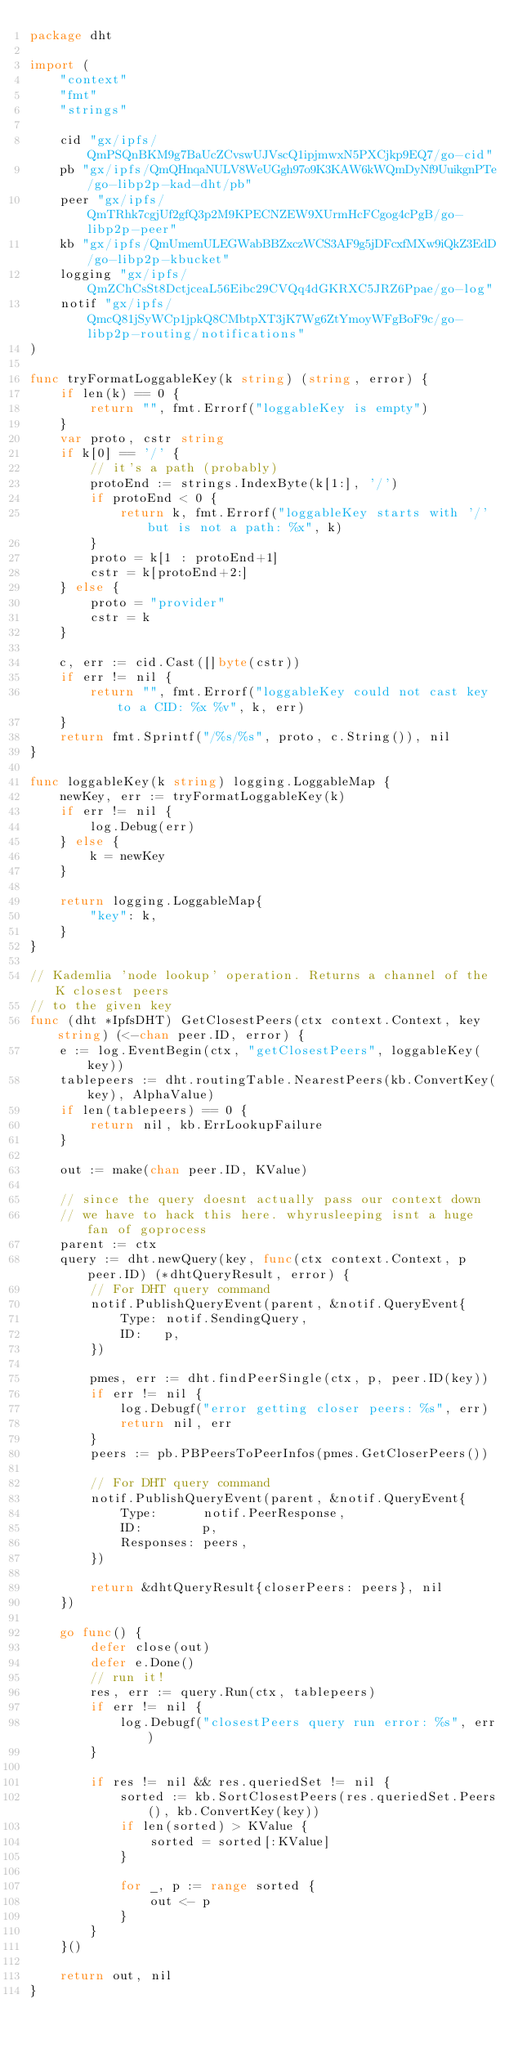Convert code to text. <code><loc_0><loc_0><loc_500><loc_500><_Go_>package dht

import (
	"context"
	"fmt"
	"strings"

	cid "gx/ipfs/QmPSQnBKM9g7BaUcZCvswUJVscQ1ipjmwxN5PXCjkp9EQ7/go-cid"
	pb "gx/ipfs/QmQHnqaNULV8WeUGgh97o9K3KAW6kWQmDyNf9UuikgnPTe/go-libp2p-kad-dht/pb"
	peer "gx/ipfs/QmTRhk7cgjUf2gfQ3p2M9KPECNZEW9XUrmHcFCgog4cPgB/go-libp2p-peer"
	kb "gx/ipfs/QmUmemULEGWabBBZxczWCS3AF9g5jDFcxfMXw9iQkZ3EdD/go-libp2p-kbucket"
	logging "gx/ipfs/QmZChCsSt8DctjceaL56Eibc29CVQq4dGKRXC5JRZ6Ppae/go-log"
	notif "gx/ipfs/QmcQ81jSyWCp1jpkQ8CMbtpXT3jK7Wg6ZtYmoyWFgBoF9c/go-libp2p-routing/notifications"
)

func tryFormatLoggableKey(k string) (string, error) {
	if len(k) == 0 {
		return "", fmt.Errorf("loggableKey is empty")
	}
	var proto, cstr string
	if k[0] == '/' {
		// it's a path (probably)
		protoEnd := strings.IndexByte(k[1:], '/')
		if protoEnd < 0 {
			return k, fmt.Errorf("loggableKey starts with '/' but is not a path: %x", k)
		}
		proto = k[1 : protoEnd+1]
		cstr = k[protoEnd+2:]
	} else {
		proto = "provider"
		cstr = k
	}

	c, err := cid.Cast([]byte(cstr))
	if err != nil {
		return "", fmt.Errorf("loggableKey could not cast key to a CID: %x %v", k, err)
	}
	return fmt.Sprintf("/%s/%s", proto, c.String()), nil
}

func loggableKey(k string) logging.LoggableMap {
	newKey, err := tryFormatLoggableKey(k)
	if err != nil {
		log.Debug(err)
	} else {
		k = newKey
	}

	return logging.LoggableMap{
		"key": k,
	}
}

// Kademlia 'node lookup' operation. Returns a channel of the K closest peers
// to the given key
func (dht *IpfsDHT) GetClosestPeers(ctx context.Context, key string) (<-chan peer.ID, error) {
	e := log.EventBegin(ctx, "getClosestPeers", loggableKey(key))
	tablepeers := dht.routingTable.NearestPeers(kb.ConvertKey(key), AlphaValue)
	if len(tablepeers) == 0 {
		return nil, kb.ErrLookupFailure
	}

	out := make(chan peer.ID, KValue)

	// since the query doesnt actually pass our context down
	// we have to hack this here. whyrusleeping isnt a huge fan of goprocess
	parent := ctx
	query := dht.newQuery(key, func(ctx context.Context, p peer.ID) (*dhtQueryResult, error) {
		// For DHT query command
		notif.PublishQueryEvent(parent, &notif.QueryEvent{
			Type: notif.SendingQuery,
			ID:   p,
		})

		pmes, err := dht.findPeerSingle(ctx, p, peer.ID(key))
		if err != nil {
			log.Debugf("error getting closer peers: %s", err)
			return nil, err
		}
		peers := pb.PBPeersToPeerInfos(pmes.GetCloserPeers())

		// For DHT query command
		notif.PublishQueryEvent(parent, &notif.QueryEvent{
			Type:      notif.PeerResponse,
			ID:        p,
			Responses: peers,
		})

		return &dhtQueryResult{closerPeers: peers}, nil
	})

	go func() {
		defer close(out)
		defer e.Done()
		// run it!
		res, err := query.Run(ctx, tablepeers)
		if err != nil {
			log.Debugf("closestPeers query run error: %s", err)
		}

		if res != nil && res.queriedSet != nil {
			sorted := kb.SortClosestPeers(res.queriedSet.Peers(), kb.ConvertKey(key))
			if len(sorted) > KValue {
				sorted = sorted[:KValue]
			}

			for _, p := range sorted {
				out <- p
			}
		}
	}()

	return out, nil
}
</code> 